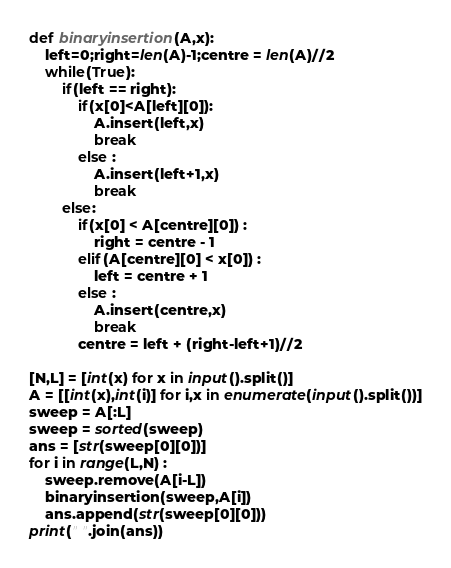Convert code to text. <code><loc_0><loc_0><loc_500><loc_500><_Python_>def binaryinsertion(A,x):
    left=0;right=len(A)-1;centre = len(A)//2
    while(True):
        if(left == right):
            if(x[0]<A[left][0]):
                A.insert(left,x)
                break
            else :
                A.insert(left+1,x)
                break
        else:
            if(x[0] < A[centre][0]) :
                right = centre - 1
            elif(A[centre][0] < x[0]) :
                left = centre + 1
            else : 
                A.insert(centre,x)
                break
            centre = left + (right-left+1)//2

[N,L] = [int(x) for x in input().split()]
A = [[int(x),int(i)] for i,x in enumerate(input().split())]
sweep = A[:L]
sweep = sorted(sweep)
ans = [str(sweep[0][0])]
for i in range(L,N) :
    sweep.remove(A[i-L])
    binaryinsertion(sweep,A[i])
    ans.append(str(sweep[0][0]))
print(" ".join(ans))</code> 